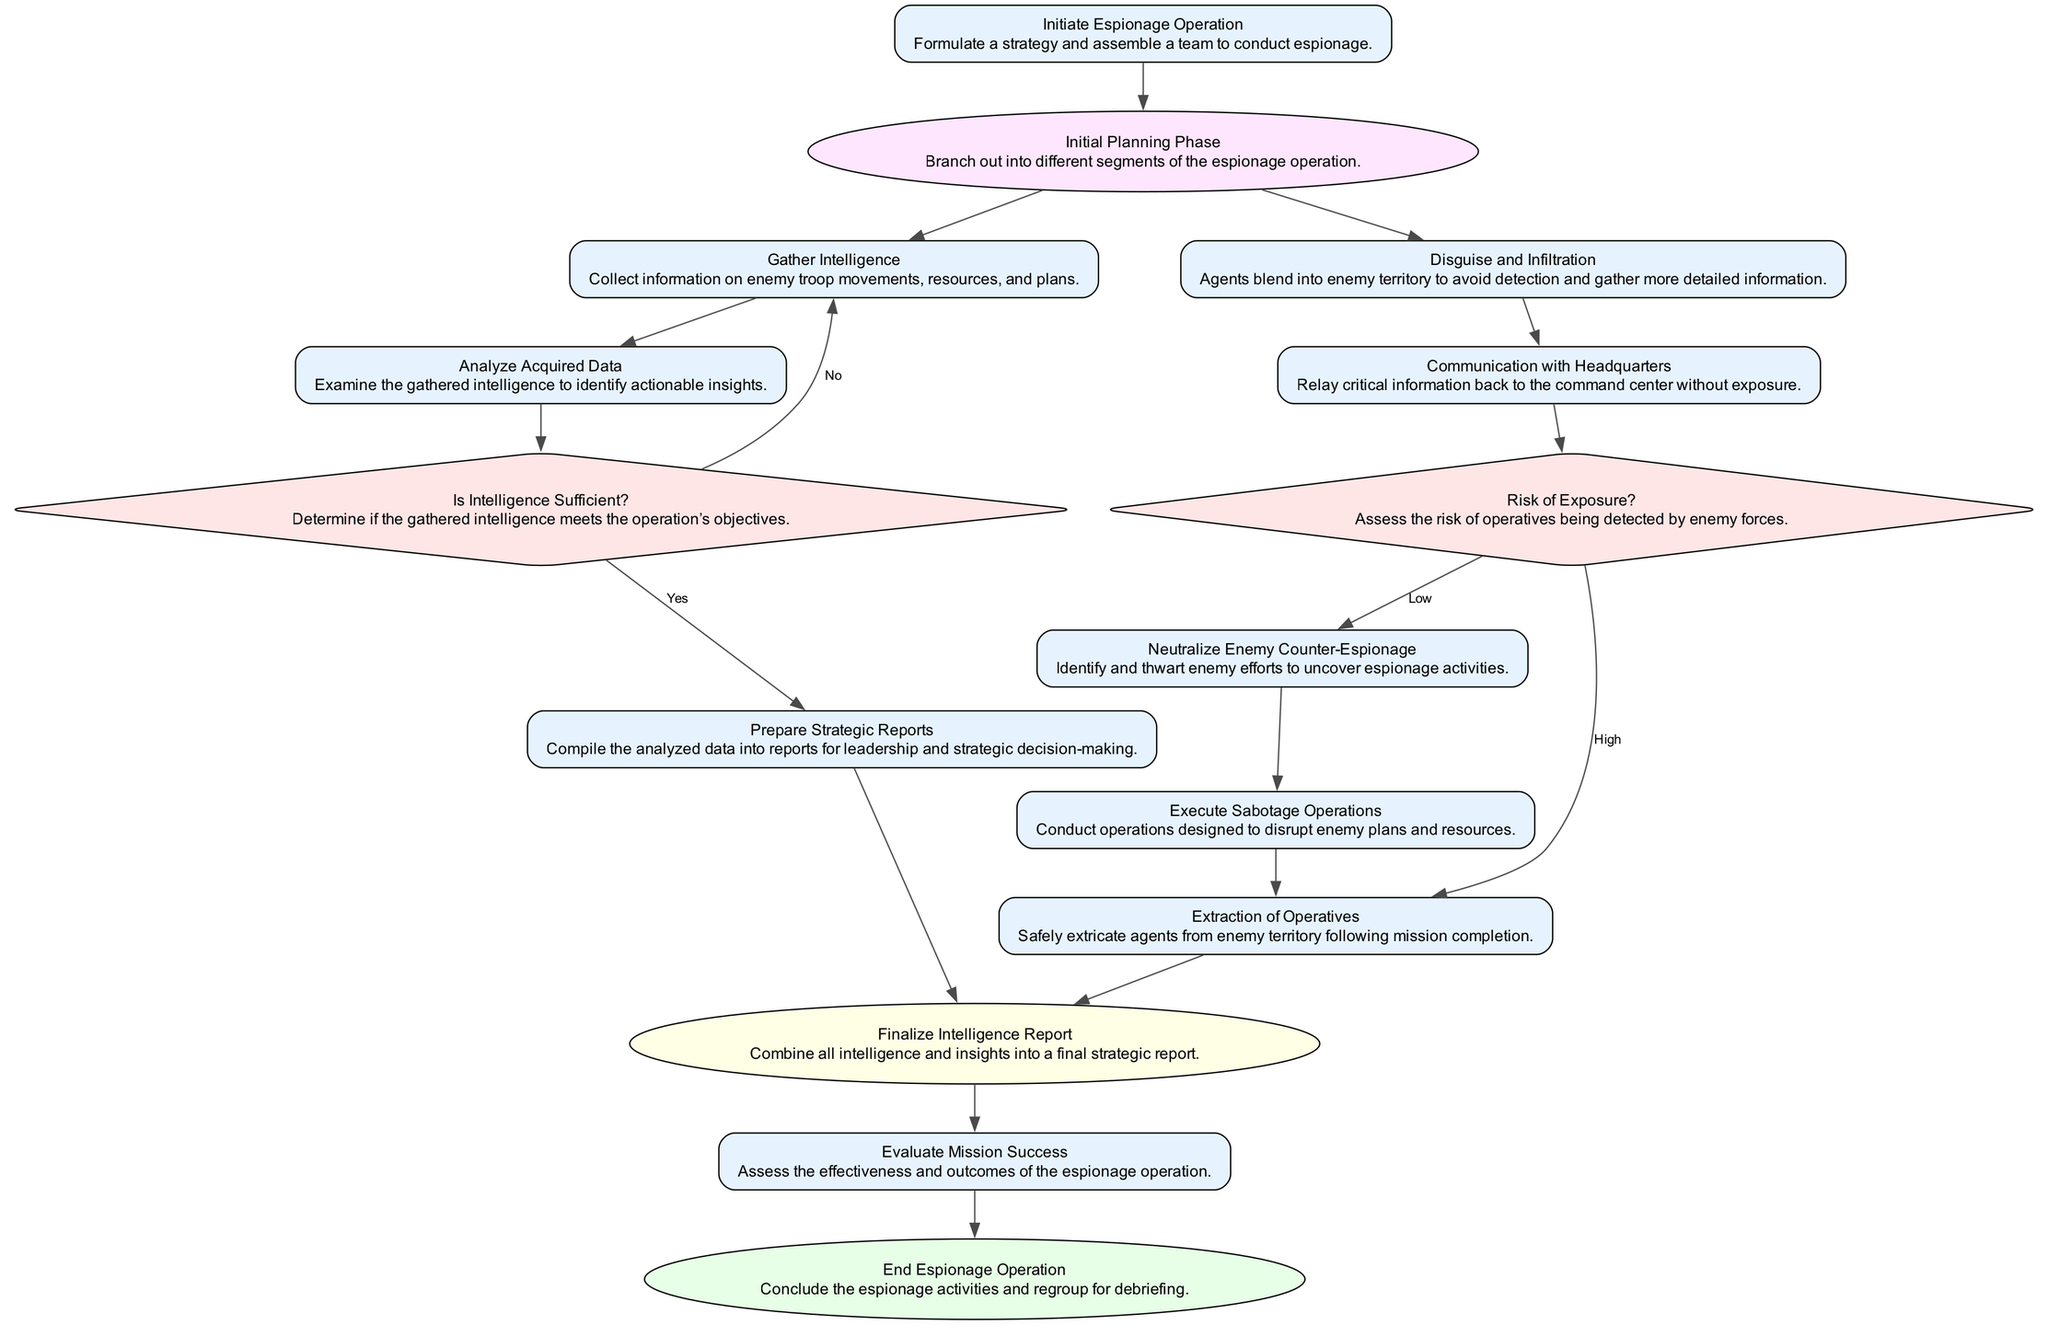What is the first activity in the espionage operation? The first activity in the diagram is "Initiate Espionage Operation," which is where the operation starts and involves formulating a strategy and assembling a team.
Answer: Initiate Espionage Operation How many decisions are depicted in the diagram? The diagram features two decisions: "Is Intelligence Sufficient?" and "Risk of Exposure?" By counting these distinctly, we arrive at the total number of decisions in the diagram.
Answer: 2 Which activity does "Analyze Acquired Data" lead to if intelligence is sufficient? If intelligence is sufficient, "Analyze Acquired Data" leads to "Prepare Strategic Reports." This follows the decision-making process shown in the diagram where sufficient intelligence leads to further reporting activities.
Answer: Prepare Strategic Reports What action is taken when the risk of exposure is assessed as low? When the risk of exposure is assessed as low, the action taken is "Neutralize Enemy Counter-Espionage." This indicates a proactive measure taken to mitigate any potential counter-espionage actions by the enemy.
Answer: Neutralize Enemy Counter-Espionage What is the final node of the espionage operation? The final node of the espionage operation is "End Espionage Operation," which indicates the conclusion of all espionage activities, signifying a regrouping for debriefing.
Answer: End Espionage Operation What does the "Initial Planning Phase" connect to? The "Initial Planning Phase" connects to two activities: "Gather Intelligence" and "Disguise and Infiltration." This indicates branching activities that follow the initial planning.
Answer: Gather Intelligence and Disguise and Infiltration How many nodes are directly connected to the decision "Is Intelligence Sufficient?" The decision "Is Intelligence Sufficient?" has two direct connections: it leads to "Prepare Strategic Reports" if yes and returns to "Gather Intelligence" if no, indicating it has two outputs.
Answer: 2 What is the relationship between "Extraction of Operatives" and "Finalize Intelligence Report"? "Extraction of Operatives" feeds into "Finalize Intelligence Report," indicating that the extraction follows the completion of the mission and contributes to the final report consolidating intelligence gathered.
Answer: Finalize Intelligence Report 